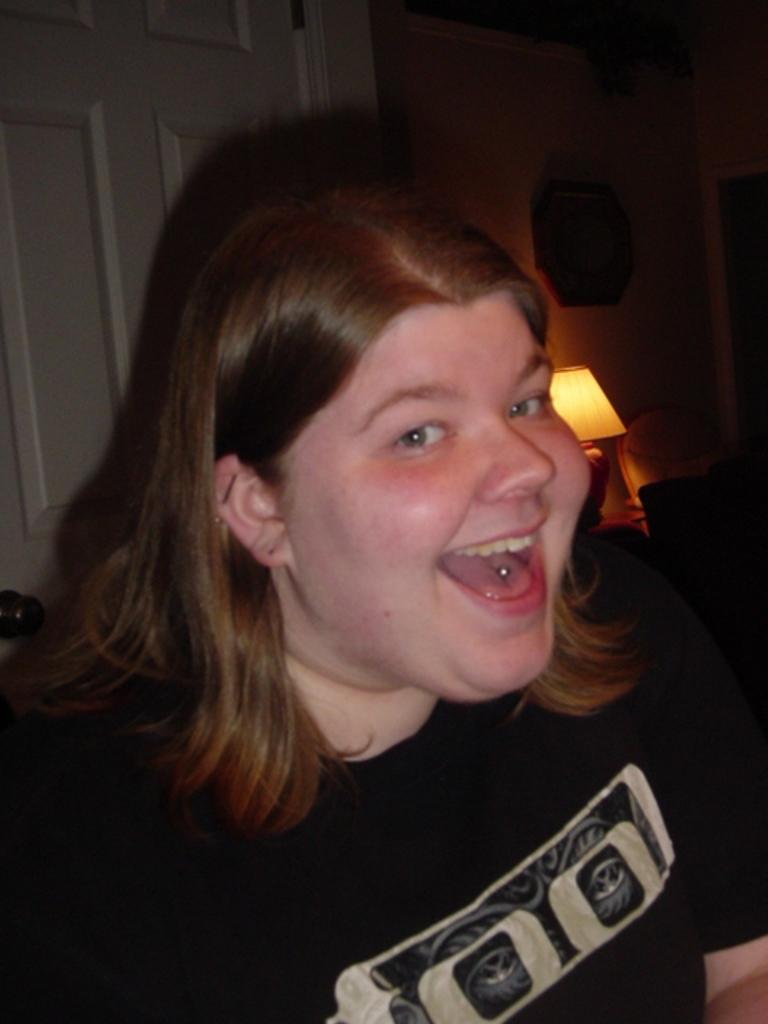Who is present in the image? There is a lady in the image. What is the lady doing in the image? The lady is smiling in the image. What is the lady wearing in the image? The lady is wearing a black shirt in the image. What can be seen in the background of the image? There is a wall, a door, and a lamp in the background of the image. What type of hammer can be seen in the lady's hand in the image? There is no hammer present in the image. Can you describe the fangs of the lady in the image? The lady does not have fangs, as she is a human and not an animal. 